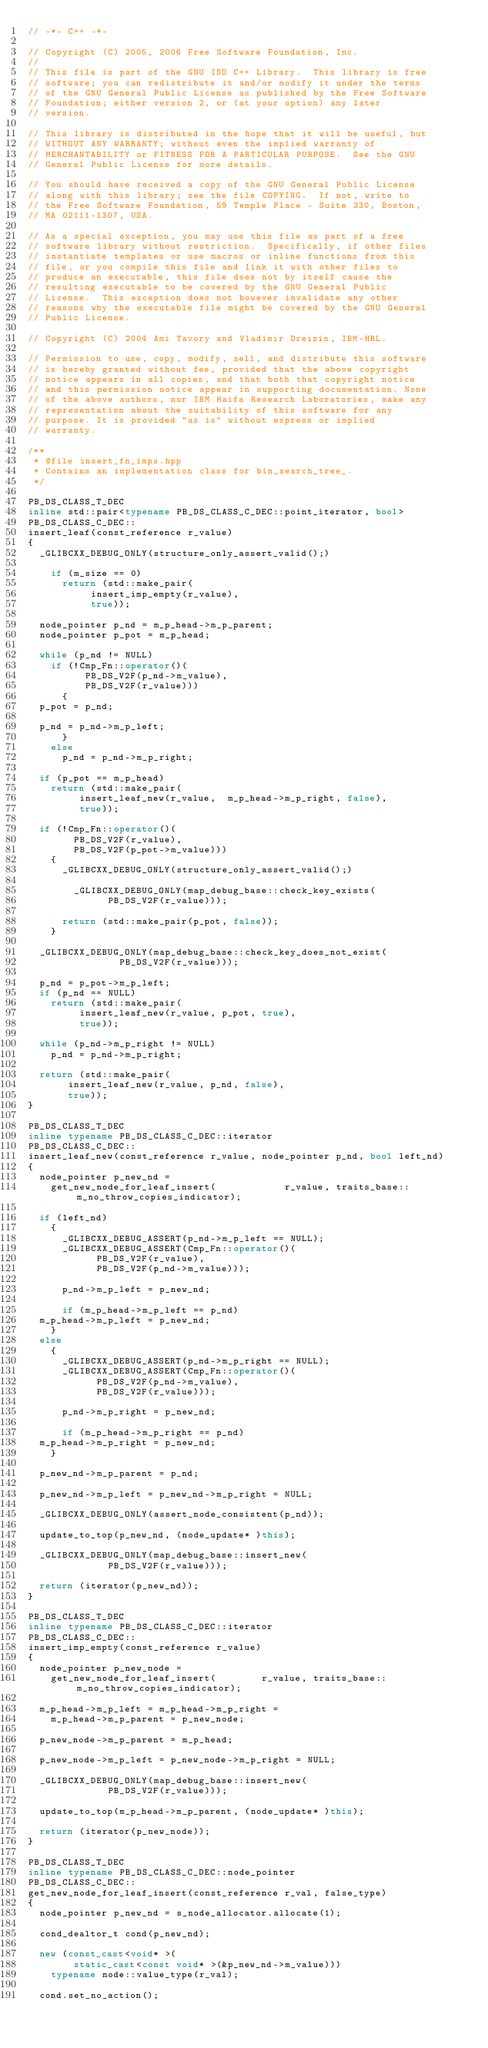<code> <loc_0><loc_0><loc_500><loc_500><_C++_>// -*- C++ -*-

// Copyright (C) 2005, 2006 Free Software Foundation, Inc.
//
// This file is part of the GNU ISO C++ Library.  This library is free
// software; you can redistribute it and/or modify it under the terms
// of the GNU General Public License as published by the Free Software
// Foundation; either version 2, or (at your option) any later
// version.

// This library is distributed in the hope that it will be useful, but
// WITHOUT ANY WARRANTY; without even the implied warranty of
// MERCHANTABILITY or FITNESS FOR A PARTICULAR PURPOSE.  See the GNU
// General Public License for more details.

// You should have received a copy of the GNU General Public License
// along with this library; see the file COPYING.  If not, write to
// the Free Software Foundation, 59 Temple Place - Suite 330, Boston,
// MA 02111-1307, USA.

// As a special exception, you may use this file as part of a free
// software library without restriction.  Specifically, if other files
// instantiate templates or use macros or inline functions from this
// file, or you compile this file and link it with other files to
// produce an executable, this file does not by itself cause the
// resulting executable to be covered by the GNU General Public
// License.  This exception does not however invalidate any other
// reasons why the executable file might be covered by the GNU General
// Public License.

// Copyright (C) 2004 Ami Tavory and Vladimir Dreizin, IBM-HRL.

// Permission to use, copy, modify, sell, and distribute this software
// is hereby granted without fee, provided that the above copyright
// notice appears in all copies, and that both that copyright notice
// and this permission notice appear in supporting documentation. None
// of the above authors, nor IBM Haifa Research Laboratories, make any
// representation about the suitability of this software for any
// purpose. It is provided "as is" without express or implied
// warranty.

/**
 * @file insert_fn_imps.hpp
 * Contains an implementation class for bin_search_tree_.
 */

PB_DS_CLASS_T_DEC
inline std::pair<typename PB_DS_CLASS_C_DEC::point_iterator, bool>
PB_DS_CLASS_C_DEC::
insert_leaf(const_reference r_value)
{
  _GLIBCXX_DEBUG_ONLY(structure_only_assert_valid();)

    if (m_size == 0)
      return (std::make_pair(
			     insert_imp_empty(r_value),
			     true));

  node_pointer p_nd = m_p_head->m_p_parent;
  node_pointer p_pot = m_p_head;

  while (p_nd != NULL)
    if (!Cmp_Fn::operator()(
			    PB_DS_V2F(p_nd->m_value),
			    PB_DS_V2F(r_value)))
      {
	p_pot = p_nd;

	p_nd = p_nd->m_p_left;
      }
    else
      p_nd = p_nd->m_p_right;

  if (p_pot == m_p_head)
    return (std::make_pair(
			   insert_leaf_new(r_value,  m_p_head->m_p_right, false),
			   true));

  if (!Cmp_Fn::operator()(
			  PB_DS_V2F(r_value),
			  PB_DS_V2F(p_pot->m_value)))
    {
      _GLIBCXX_DEBUG_ONLY(structure_only_assert_valid();)

        _GLIBCXX_DEBUG_ONLY(map_debug_base::check_key_exists(
							PB_DS_V2F(r_value)));

      return (std::make_pair(p_pot, false));
    }

  _GLIBCXX_DEBUG_ONLY(map_debug_base::check_key_does_not_exist(
							  PB_DS_V2F(r_value)));

  p_nd = p_pot->m_p_left;
  if (p_nd == NULL)
    return (std::make_pair(
			   insert_leaf_new(r_value, p_pot, true),
			   true));

  while (p_nd->m_p_right != NULL)
    p_nd = p_nd->m_p_right;

  return (std::make_pair(
			 insert_leaf_new(r_value, p_nd, false),
			 true));
}

PB_DS_CLASS_T_DEC
inline typename PB_DS_CLASS_C_DEC::iterator
PB_DS_CLASS_C_DEC::
insert_leaf_new(const_reference r_value, node_pointer p_nd, bool left_nd)
{
  node_pointer p_new_nd =
    get_new_node_for_leaf_insert(            r_value, traits_base::m_no_throw_copies_indicator);

  if (left_nd)
    {
      _GLIBCXX_DEBUG_ASSERT(p_nd->m_p_left == NULL);
      _GLIBCXX_DEBUG_ASSERT(Cmp_Fn::operator()(
					  PB_DS_V2F(r_value),
					  PB_DS_V2F(p_nd->m_value)));

      p_nd->m_p_left = p_new_nd;

      if (m_p_head->m_p_left == p_nd)
	m_p_head->m_p_left = p_new_nd;
    }
  else
    {
      _GLIBCXX_DEBUG_ASSERT(p_nd->m_p_right == NULL);
      _GLIBCXX_DEBUG_ASSERT(Cmp_Fn::operator()(
					  PB_DS_V2F(p_nd->m_value),
					  PB_DS_V2F(r_value)));

      p_nd->m_p_right = p_new_nd;

      if (m_p_head->m_p_right == p_nd)
	m_p_head->m_p_right = p_new_nd;
    }

  p_new_nd->m_p_parent = p_nd;

  p_new_nd->m_p_left = p_new_nd->m_p_right = NULL;

  _GLIBCXX_DEBUG_ONLY(assert_node_consistent(p_nd));

  update_to_top(p_new_nd, (node_update* )this);

  _GLIBCXX_DEBUG_ONLY(map_debug_base::insert_new(
					    PB_DS_V2F(r_value)));

  return (iterator(p_new_nd));
}

PB_DS_CLASS_T_DEC
inline typename PB_DS_CLASS_C_DEC::iterator
PB_DS_CLASS_C_DEC::
insert_imp_empty(const_reference r_value)
{
  node_pointer p_new_node =
    get_new_node_for_leaf_insert(        r_value, traits_base::m_no_throw_copies_indicator);

  m_p_head->m_p_left = m_p_head->m_p_right =
    m_p_head->m_p_parent = p_new_node;

  p_new_node->m_p_parent = m_p_head;

  p_new_node->m_p_left = p_new_node->m_p_right = NULL;

  _GLIBCXX_DEBUG_ONLY(map_debug_base::insert_new(
					    PB_DS_V2F(r_value)));

  update_to_top(m_p_head->m_p_parent, (node_update* )this);

  return (iterator(p_new_node));
}

PB_DS_CLASS_T_DEC
inline typename PB_DS_CLASS_C_DEC::node_pointer
PB_DS_CLASS_C_DEC::
get_new_node_for_leaf_insert(const_reference r_val, false_type)
{
  node_pointer p_new_nd = s_node_allocator.allocate(1);

  cond_dealtor_t cond(p_new_nd);

  new (const_cast<void* >(
			  static_cast<const void* >(&p_new_nd->m_value)))
    typename node::value_type(r_val);

  cond.set_no_action();
</code> 